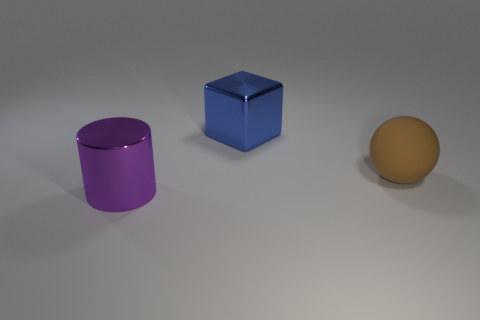Is there any other thing that has the same material as the brown object?
Offer a very short reply. No. How many yellow objects are large shiny blocks or big shiny objects?
Give a very brief answer. 0. The object that is left of the brown thing and in front of the large blue object is what color?
Ensure brevity in your answer.  Purple. How many large things are metal objects or blue cubes?
Keep it short and to the point. 2. What is the shape of the rubber thing?
Keep it short and to the point. Sphere. Does the large blue block have the same material as the large thing left of the large blue block?
Your response must be concise. Yes. What number of matte objects are either blue balls or large things?
Offer a terse response. 1. What is the size of the thing in front of the large brown rubber ball?
Your response must be concise. Large. There is a object that is the same material as the big cube; what size is it?
Your answer should be compact. Large. What number of big spheres are the same color as the cylinder?
Ensure brevity in your answer.  0. 